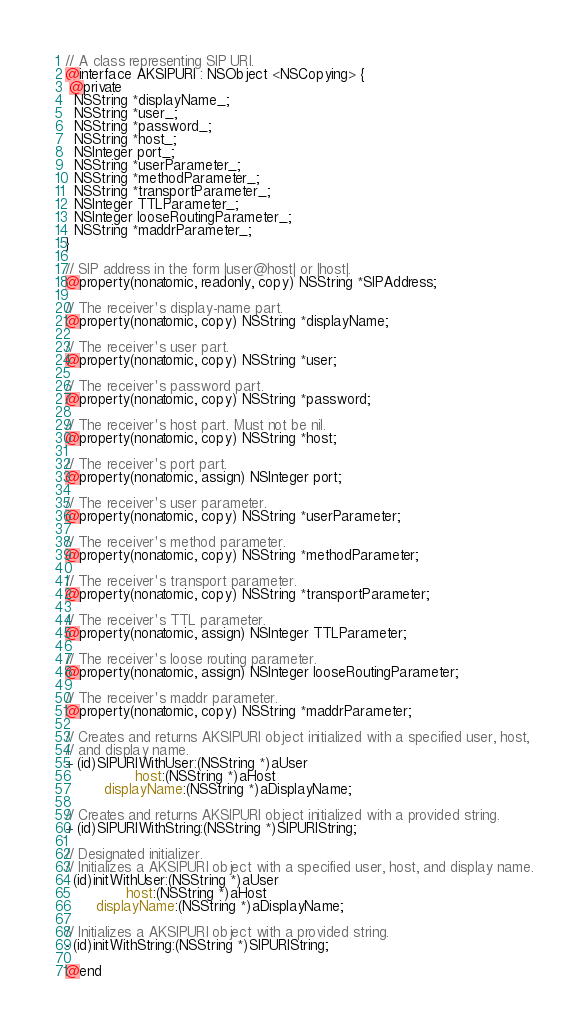<code> <loc_0><loc_0><loc_500><loc_500><_C_>// A class representing SIP URI.
@interface AKSIPURI : NSObject <NSCopying> {
 @private
  NSString *displayName_;
  NSString *user_;
  NSString *password_;
  NSString *host_;
  NSInteger port_;
  NSString *userParameter_;
  NSString *methodParameter_;
  NSString *transportParameter_;
  NSInteger TTLParameter_;
  NSInteger looseRoutingParameter_;
  NSString *maddrParameter_;
}

// SIP address in the form |user@host| or |host|.
@property(nonatomic, readonly, copy) NSString *SIPAddress;

// The receiver's display-name part.
@property(nonatomic, copy) NSString *displayName;

// The receiver's user part.
@property(nonatomic, copy) NSString *user;

// The receiver's password part.
@property(nonatomic, copy) NSString *password;

// The receiver's host part. Must not be nil.
@property(nonatomic, copy) NSString *host;

// The receiver's port part.
@property(nonatomic, assign) NSInteger port;

// The receiver's user parameter.
@property(nonatomic, copy) NSString *userParameter;

// The receiver's method parameter.
@property(nonatomic, copy) NSString *methodParameter;

// The receiver's transport parameter.
@property(nonatomic, copy) NSString *transportParameter;

// The receiver's TTL parameter.
@property(nonatomic, assign) NSInteger TTLParameter;

// The receiver's loose routing parameter.
@property(nonatomic, assign) NSInteger looseRoutingParameter;

// The receiver's maddr parameter.
@property(nonatomic, copy) NSString *maddrParameter;

// Creates and returns AKSIPURI object initialized with a specified user, host,
// and display name.
+ (id)SIPURIWithUser:(NSString *)aUser
                host:(NSString *)aHost
         displayName:(NSString *)aDisplayName;

// Creates and returns AKSIPURI object initialized with a provided string.
+ (id)SIPURIWithString:(NSString *)SIPURIString;

// Designated initializer.
// Initializes a AKSIPURI object with a specified user, host, and display name.
- (id)initWithUser:(NSString *)aUser
              host:(NSString *)aHost
       displayName:(NSString *)aDisplayName;

// Initializes a AKSIPURI object with a provided string.
- (id)initWithString:(NSString *)SIPURIString;

@end
</code> 